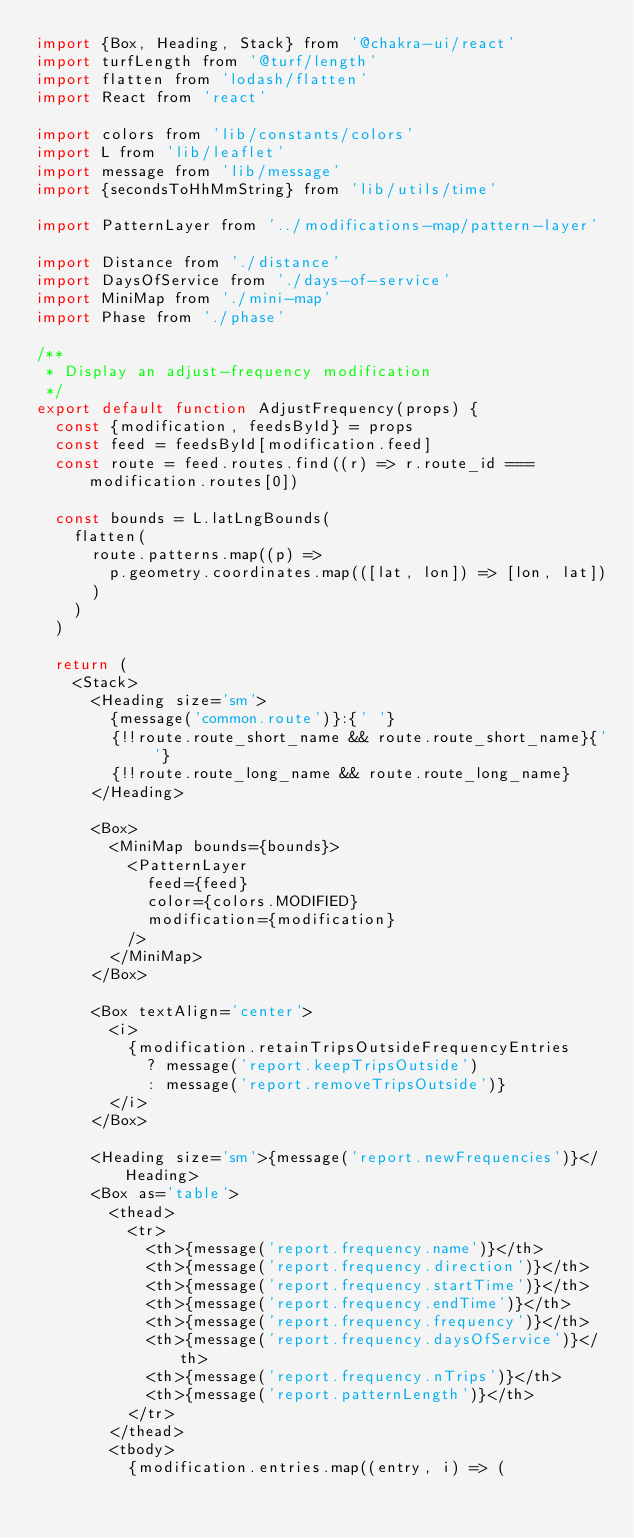<code> <loc_0><loc_0><loc_500><loc_500><_JavaScript_>import {Box, Heading, Stack} from '@chakra-ui/react'
import turfLength from '@turf/length'
import flatten from 'lodash/flatten'
import React from 'react'

import colors from 'lib/constants/colors'
import L from 'lib/leaflet'
import message from 'lib/message'
import {secondsToHhMmString} from 'lib/utils/time'

import PatternLayer from '../modifications-map/pattern-layer'

import Distance from './distance'
import DaysOfService from './days-of-service'
import MiniMap from './mini-map'
import Phase from './phase'

/**
 * Display an adjust-frequency modification
 */
export default function AdjustFrequency(props) {
  const {modification, feedsById} = props
  const feed = feedsById[modification.feed]
  const route = feed.routes.find((r) => r.route_id === modification.routes[0])

  const bounds = L.latLngBounds(
    flatten(
      route.patterns.map((p) =>
        p.geometry.coordinates.map(([lat, lon]) => [lon, lat])
      )
    )
  )

  return (
    <Stack>
      <Heading size='sm'>
        {message('common.route')}:{' '}
        {!!route.route_short_name && route.route_short_name}{' '}
        {!!route.route_long_name && route.route_long_name}
      </Heading>

      <Box>
        <MiniMap bounds={bounds}>
          <PatternLayer
            feed={feed}
            color={colors.MODIFIED}
            modification={modification}
          />
        </MiniMap>
      </Box>

      <Box textAlign='center'>
        <i>
          {modification.retainTripsOutsideFrequencyEntries
            ? message('report.keepTripsOutside')
            : message('report.removeTripsOutside')}
        </i>
      </Box>

      <Heading size='sm'>{message('report.newFrequencies')}</Heading>
      <Box as='table'>
        <thead>
          <tr>
            <th>{message('report.frequency.name')}</th>
            <th>{message('report.frequency.direction')}</th>
            <th>{message('report.frequency.startTime')}</th>
            <th>{message('report.frequency.endTime')}</th>
            <th>{message('report.frequency.frequency')}</th>
            <th>{message('report.frequency.daysOfService')}</th>
            <th>{message('report.frequency.nTrips')}</th>
            <th>{message('report.patternLength')}</th>
          </tr>
        </thead>
        <tbody>
          {modification.entries.map((entry, i) => (</code> 